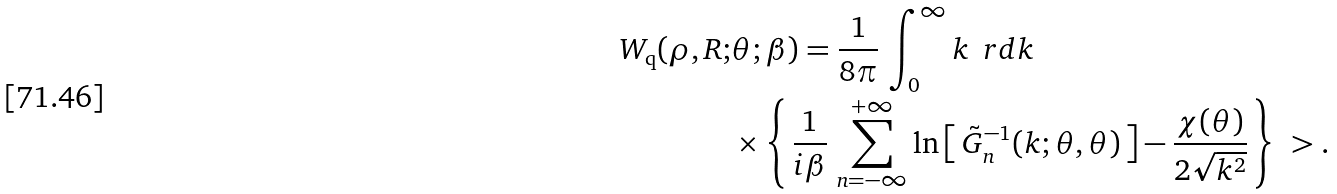<formula> <loc_0><loc_0><loc_500><loc_500>W _ { \text {q} } ( \rho , R ; & \theta ; \beta ) = \frac { 1 } { 8 \pi } \, \int _ { 0 } ^ { \infty } k \, \ r d k \\ & \times \left \{ \, \frac { 1 } { i \beta } \, \sum _ { n = - \infty } ^ { + \infty } \ln \left [ \, \tilde { G } _ { n } ^ { - 1 } ( k ; \theta , \theta ) \, \right ] - \frac { \chi ( \theta ) } { 2 \sqrt { k ^ { 2 } } } \, \right \} \ > .</formula> 